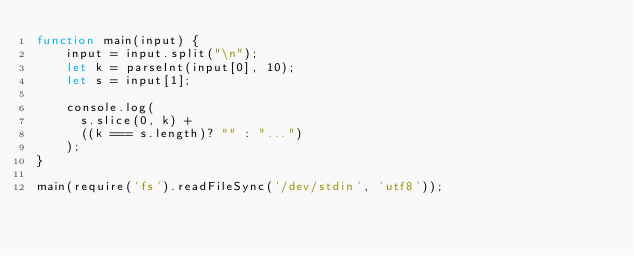Convert code to text. <code><loc_0><loc_0><loc_500><loc_500><_JavaScript_>function main(input) {
	input = input.split("\n");
  	let k = parseInt(input[0], 10);
  	let s = input[1];
  
  	console.log(
      s.slice(0, k) + 
      ((k === s.length)? "" : "...")
    );
}
 
main(require('fs').readFileSync('/dev/stdin', 'utf8'));</code> 